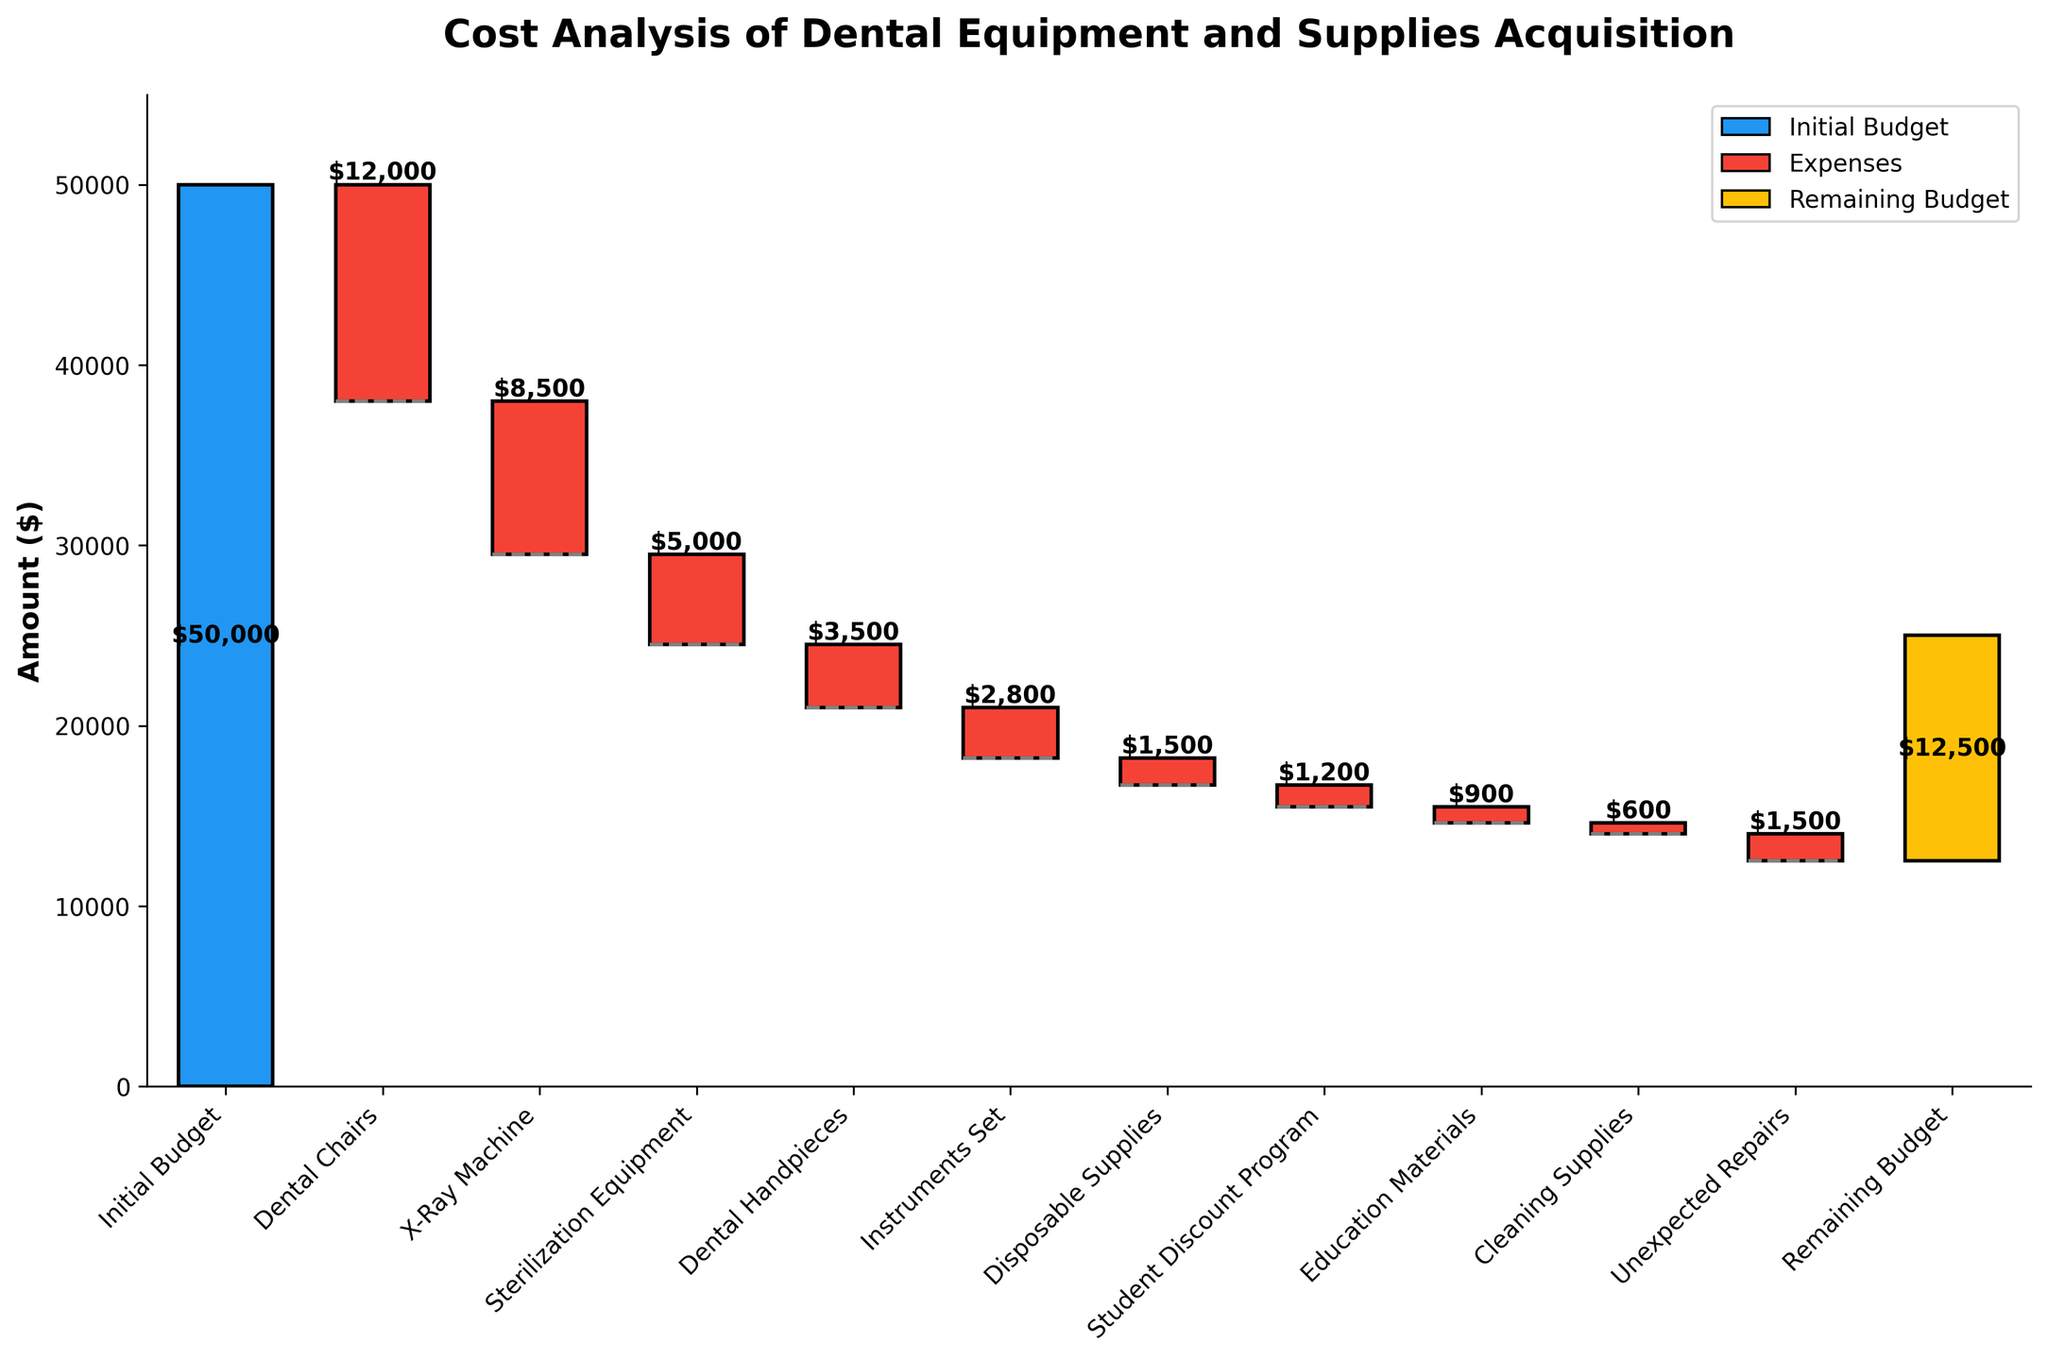What is the title of the chart? The title of the chart is prominently displayed at the top and clearly states the topic of the analysis.
Answer: Cost Analysis of Dental Equipment and Supplies Acquisition How many categories are displayed in the chart? The x-axis of the chart lists all the categories involved in the cost analysis. By counting these categories, you can determine the total number.
Answer: 12 Which category has the highest cost? The largest negative bar on the chart indicates the category with the highest cost. Looking at the bars, the largest downward bar will show this.
Answer: Dental Chairs How much budget remains after all expenses? The final bar at the far right of the chart indicates the remaining budget. This bar is differentiated by color and labeled.
Answer: $12,500 What is the difference in cost between the X-Ray Machine and Sterilization Equipment? Look at the bars corresponding to the X-Ray Machine and Sterilization Equipment, then subtract the values of these categories to find the difference. -$8,500 - (-$5,000) = -$8,500 + $5,000
Answer: $3,500 How much was spent on Disposable Supplies and Cleaning Supplies combined? Find the bars representing Disposable Supplies and Cleaning Supplies, then add their values together. 
- Disposable Supplies: -$1,500 
- Cleaning Supplies: -$600 
- Sum: -$1,500 + -$600 = -$2,100
Answer: $2,100 Between Instruments Set and Education Materials, which costs more, and by how much? Observe the bars for Instruments Set and Education Materials. Subtract the value of the smaller cost from the larger cost to determine the difference.
Answer: Instruments Set costs $1,900 more (-$2,800 - -$900 = $1,900) What is the total expenditure on all items excluding the Student Discount Program? Add the values of all categories except the Student Discount Program: 
- Dental Chairs: -$12,000 
- X-Ray Machine: -$8,500 
- Sterilization Equipment: -$5,000 
- Dental Handpieces: -$3,500 
- Instruments Set: -$2,800 
- Disposable Supplies: -$1,500 
- Education Materials: -$900 
- Cleaning Supplies: -$600 
- Unexpected Repairs: -$1,500 
Sum: -($12,000 + $8,500 + $5,000 + $3,500 + $2,800 + $1,500 + $900 + $600 + $1,500) = -$36,300
Answer: $36,300 What color is used to represent the Initial Budget? The Initial Budget category has a distinct color from the other categories, and the color code can be seen clearly.
Answer: Blue If the Unexpected Repairs cost was omitted, what would be the remaining budget? The current remaining budget is $12,500, including the Unexpected Repairs. 
- Remaining Budget + Unexpected Repairs: $12,500 + $1,500
Answer: $14,000 en 